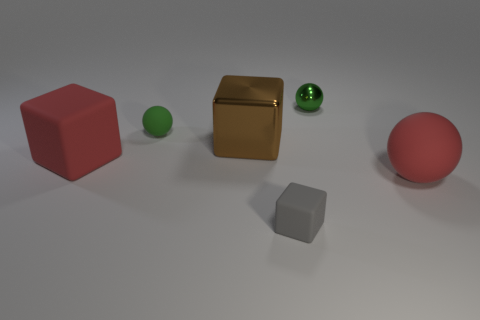How many other small spheres have the same material as the red sphere?
Offer a terse response. 1. Is the shape of the tiny green matte thing the same as the tiny green object that is to the right of the shiny cube?
Provide a short and direct response. Yes. Are there any big matte objects on the right side of the large block that is to the right of the green sphere to the left of the tiny green metal thing?
Provide a short and direct response. Yes. What size is the red rubber object to the right of the big brown metallic object?
Offer a terse response. Large. There is a green object that is the same size as the green rubber ball; what material is it?
Your answer should be very brief. Metal. Does the tiny green metallic object have the same shape as the tiny green matte object?
Offer a very short reply. Yes. How many objects are either green matte spheres or rubber spheres that are on the left side of the brown metallic block?
Give a very brief answer. 1. What is the material of the cube that is the same color as the large sphere?
Keep it short and to the point. Rubber. There is a rubber sphere that is left of the brown shiny thing; is it the same size as the shiny ball?
Make the answer very short. Yes. There is a red rubber object that is on the left side of the small green sphere that is in front of the tiny green metal sphere; what number of red balls are on the right side of it?
Provide a succinct answer. 1. 